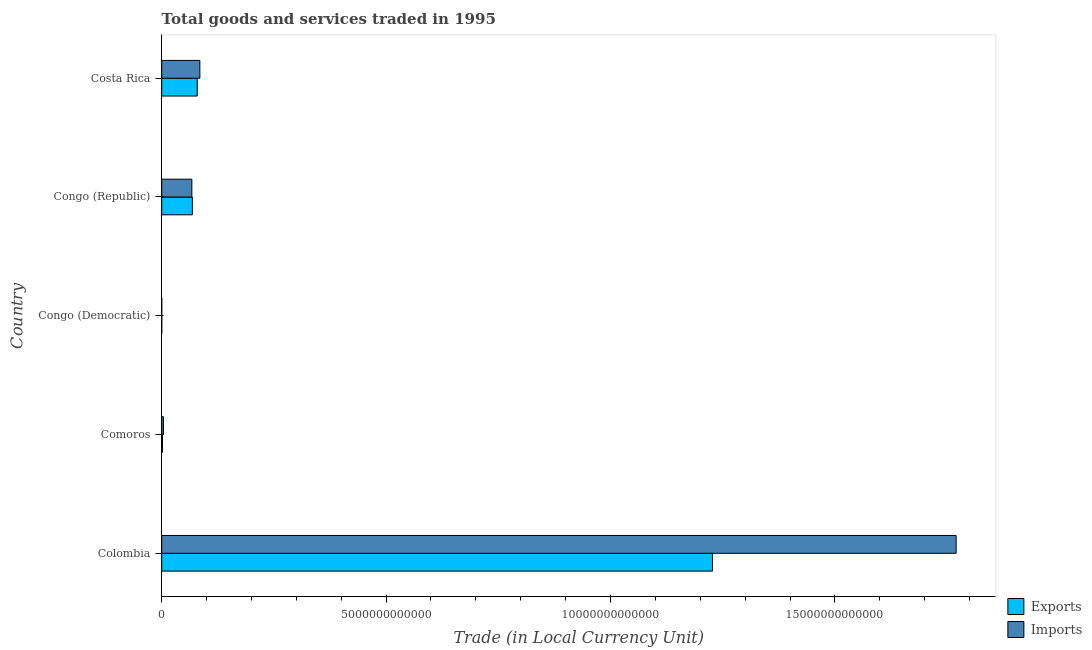How many different coloured bars are there?
Offer a very short reply. 2. How many groups of bars are there?
Ensure brevity in your answer.  5. Are the number of bars per tick equal to the number of legend labels?
Keep it short and to the point. Yes. What is the label of the 4th group of bars from the top?
Provide a succinct answer. Comoros. What is the export of goods and services in Costa Rica?
Your answer should be very brief. 7.91e+11. Across all countries, what is the maximum imports of goods and services?
Keep it short and to the point. 1.77e+13. Across all countries, what is the minimum imports of goods and services?
Your answer should be very brief. 9.41e+07. In which country was the export of goods and services minimum?
Give a very brief answer. Congo (Democratic). What is the total export of goods and services in the graph?
Your response must be concise. 1.38e+13. What is the difference between the imports of goods and services in Colombia and that in Congo (Democratic)?
Your response must be concise. 1.77e+13. What is the difference between the export of goods and services in Congo (Democratic) and the imports of goods and services in Congo (Republic)?
Your response must be concise. -6.72e+11. What is the average imports of goods and services per country?
Ensure brevity in your answer.  3.85e+12. What is the difference between the imports of goods and services and export of goods and services in Congo (Republic)?
Offer a terse response. -1.16e+1. What is the ratio of the export of goods and services in Comoros to that in Congo (Democratic)?
Your answer should be compact. 151.95. What is the difference between the highest and the second highest export of goods and services?
Offer a terse response. 1.15e+13. What is the difference between the highest and the lowest imports of goods and services?
Your answer should be compact. 1.77e+13. What does the 2nd bar from the top in Congo (Democratic) represents?
Your answer should be compact. Exports. What does the 2nd bar from the bottom in Comoros represents?
Give a very brief answer. Imports. How many bars are there?
Provide a short and direct response. 10. What is the difference between two consecutive major ticks on the X-axis?
Offer a terse response. 5.00e+12. Where does the legend appear in the graph?
Your response must be concise. Bottom right. How many legend labels are there?
Your answer should be very brief. 2. How are the legend labels stacked?
Provide a succinct answer. Vertical. What is the title of the graph?
Give a very brief answer. Total goods and services traded in 1995. Does "RDB nonconcessional" appear as one of the legend labels in the graph?
Provide a short and direct response. No. What is the label or title of the X-axis?
Make the answer very short. Trade (in Local Currency Unit). What is the label or title of the Y-axis?
Your answer should be compact. Country. What is the Trade (in Local Currency Unit) in Exports in Colombia?
Your answer should be very brief. 1.23e+13. What is the Trade (in Local Currency Unit) of Imports in Colombia?
Your answer should be very brief. 1.77e+13. What is the Trade (in Local Currency Unit) in Exports in Comoros?
Offer a terse response. 1.72e+1. What is the Trade (in Local Currency Unit) in Imports in Comoros?
Give a very brief answer. 3.87e+1. What is the Trade (in Local Currency Unit) of Exports in Congo (Democratic)?
Your response must be concise. 1.13e+08. What is the Trade (in Local Currency Unit) in Imports in Congo (Democratic)?
Your answer should be very brief. 9.41e+07. What is the Trade (in Local Currency Unit) in Exports in Congo (Republic)?
Offer a very short reply. 6.83e+11. What is the Trade (in Local Currency Unit) of Imports in Congo (Republic)?
Provide a succinct answer. 6.72e+11. What is the Trade (in Local Currency Unit) of Exports in Costa Rica?
Your response must be concise. 7.91e+11. What is the Trade (in Local Currency Unit) of Imports in Costa Rica?
Offer a terse response. 8.50e+11. Across all countries, what is the maximum Trade (in Local Currency Unit) in Exports?
Ensure brevity in your answer.  1.23e+13. Across all countries, what is the maximum Trade (in Local Currency Unit) of Imports?
Your answer should be very brief. 1.77e+13. Across all countries, what is the minimum Trade (in Local Currency Unit) of Exports?
Ensure brevity in your answer.  1.13e+08. Across all countries, what is the minimum Trade (in Local Currency Unit) in Imports?
Your response must be concise. 9.41e+07. What is the total Trade (in Local Currency Unit) of Exports in the graph?
Provide a succinct answer. 1.38e+13. What is the total Trade (in Local Currency Unit) in Imports in the graph?
Provide a succinct answer. 1.93e+13. What is the difference between the Trade (in Local Currency Unit) in Exports in Colombia and that in Comoros?
Provide a succinct answer. 1.23e+13. What is the difference between the Trade (in Local Currency Unit) of Imports in Colombia and that in Comoros?
Provide a short and direct response. 1.77e+13. What is the difference between the Trade (in Local Currency Unit) in Exports in Colombia and that in Congo (Democratic)?
Your answer should be compact. 1.23e+13. What is the difference between the Trade (in Local Currency Unit) of Imports in Colombia and that in Congo (Democratic)?
Offer a very short reply. 1.77e+13. What is the difference between the Trade (in Local Currency Unit) of Exports in Colombia and that in Congo (Republic)?
Make the answer very short. 1.16e+13. What is the difference between the Trade (in Local Currency Unit) of Imports in Colombia and that in Congo (Republic)?
Your answer should be compact. 1.70e+13. What is the difference between the Trade (in Local Currency Unit) of Exports in Colombia and that in Costa Rica?
Ensure brevity in your answer.  1.15e+13. What is the difference between the Trade (in Local Currency Unit) in Imports in Colombia and that in Costa Rica?
Your answer should be very brief. 1.69e+13. What is the difference between the Trade (in Local Currency Unit) in Exports in Comoros and that in Congo (Democratic)?
Your answer should be very brief. 1.70e+1. What is the difference between the Trade (in Local Currency Unit) in Imports in Comoros and that in Congo (Democratic)?
Keep it short and to the point. 3.86e+1. What is the difference between the Trade (in Local Currency Unit) in Exports in Comoros and that in Congo (Republic)?
Give a very brief answer. -6.66e+11. What is the difference between the Trade (in Local Currency Unit) in Imports in Comoros and that in Congo (Republic)?
Provide a succinct answer. -6.33e+11. What is the difference between the Trade (in Local Currency Unit) of Exports in Comoros and that in Costa Rica?
Provide a succinct answer. -7.74e+11. What is the difference between the Trade (in Local Currency Unit) of Imports in Comoros and that in Costa Rica?
Ensure brevity in your answer.  -8.11e+11. What is the difference between the Trade (in Local Currency Unit) of Exports in Congo (Democratic) and that in Congo (Republic)?
Your response must be concise. -6.83e+11. What is the difference between the Trade (in Local Currency Unit) of Imports in Congo (Democratic) and that in Congo (Republic)?
Give a very brief answer. -6.72e+11. What is the difference between the Trade (in Local Currency Unit) in Exports in Congo (Democratic) and that in Costa Rica?
Offer a very short reply. -7.91e+11. What is the difference between the Trade (in Local Currency Unit) in Imports in Congo (Democratic) and that in Costa Rica?
Ensure brevity in your answer.  -8.50e+11. What is the difference between the Trade (in Local Currency Unit) of Exports in Congo (Republic) and that in Costa Rica?
Make the answer very short. -1.07e+11. What is the difference between the Trade (in Local Currency Unit) of Imports in Congo (Republic) and that in Costa Rica?
Your response must be concise. -1.78e+11. What is the difference between the Trade (in Local Currency Unit) in Exports in Colombia and the Trade (in Local Currency Unit) in Imports in Comoros?
Give a very brief answer. 1.22e+13. What is the difference between the Trade (in Local Currency Unit) of Exports in Colombia and the Trade (in Local Currency Unit) of Imports in Congo (Democratic)?
Your response must be concise. 1.23e+13. What is the difference between the Trade (in Local Currency Unit) in Exports in Colombia and the Trade (in Local Currency Unit) in Imports in Congo (Republic)?
Your response must be concise. 1.16e+13. What is the difference between the Trade (in Local Currency Unit) of Exports in Colombia and the Trade (in Local Currency Unit) of Imports in Costa Rica?
Ensure brevity in your answer.  1.14e+13. What is the difference between the Trade (in Local Currency Unit) of Exports in Comoros and the Trade (in Local Currency Unit) of Imports in Congo (Democratic)?
Offer a terse response. 1.71e+1. What is the difference between the Trade (in Local Currency Unit) of Exports in Comoros and the Trade (in Local Currency Unit) of Imports in Congo (Republic)?
Offer a terse response. -6.55e+11. What is the difference between the Trade (in Local Currency Unit) in Exports in Comoros and the Trade (in Local Currency Unit) in Imports in Costa Rica?
Your answer should be compact. -8.33e+11. What is the difference between the Trade (in Local Currency Unit) in Exports in Congo (Democratic) and the Trade (in Local Currency Unit) in Imports in Congo (Republic)?
Offer a very short reply. -6.72e+11. What is the difference between the Trade (in Local Currency Unit) of Exports in Congo (Democratic) and the Trade (in Local Currency Unit) of Imports in Costa Rica?
Offer a terse response. -8.50e+11. What is the difference between the Trade (in Local Currency Unit) in Exports in Congo (Republic) and the Trade (in Local Currency Unit) in Imports in Costa Rica?
Give a very brief answer. -1.67e+11. What is the average Trade (in Local Currency Unit) of Exports per country?
Offer a terse response. 2.75e+12. What is the average Trade (in Local Currency Unit) of Imports per country?
Make the answer very short. 3.85e+12. What is the difference between the Trade (in Local Currency Unit) of Exports and Trade (in Local Currency Unit) of Imports in Colombia?
Make the answer very short. -5.43e+12. What is the difference between the Trade (in Local Currency Unit) in Exports and Trade (in Local Currency Unit) in Imports in Comoros?
Keep it short and to the point. -2.15e+1. What is the difference between the Trade (in Local Currency Unit) in Exports and Trade (in Local Currency Unit) in Imports in Congo (Democratic)?
Offer a terse response. 1.89e+07. What is the difference between the Trade (in Local Currency Unit) in Exports and Trade (in Local Currency Unit) in Imports in Congo (Republic)?
Provide a short and direct response. 1.16e+1. What is the difference between the Trade (in Local Currency Unit) of Exports and Trade (in Local Currency Unit) of Imports in Costa Rica?
Provide a succinct answer. -5.92e+1. What is the ratio of the Trade (in Local Currency Unit) of Exports in Colombia to that in Comoros?
Offer a very short reply. 715.29. What is the ratio of the Trade (in Local Currency Unit) in Imports in Colombia to that in Comoros?
Your answer should be compact. 457.53. What is the ratio of the Trade (in Local Currency Unit) in Exports in Colombia to that in Congo (Democratic)?
Give a very brief answer. 1.09e+05. What is the ratio of the Trade (in Local Currency Unit) in Imports in Colombia to that in Congo (Democratic)?
Provide a succinct answer. 1.88e+05. What is the ratio of the Trade (in Local Currency Unit) in Exports in Colombia to that in Congo (Republic)?
Offer a very short reply. 17.96. What is the ratio of the Trade (in Local Currency Unit) in Imports in Colombia to that in Congo (Republic)?
Your answer should be compact. 26.35. What is the ratio of the Trade (in Local Currency Unit) of Exports in Colombia to that in Costa Rica?
Make the answer very short. 15.52. What is the ratio of the Trade (in Local Currency Unit) in Imports in Colombia to that in Costa Rica?
Give a very brief answer. 20.83. What is the ratio of the Trade (in Local Currency Unit) of Exports in Comoros to that in Congo (Democratic)?
Your response must be concise. 151.95. What is the ratio of the Trade (in Local Currency Unit) of Imports in Comoros to that in Congo (Democratic)?
Your response must be concise. 411.34. What is the ratio of the Trade (in Local Currency Unit) of Exports in Comoros to that in Congo (Republic)?
Your response must be concise. 0.03. What is the ratio of the Trade (in Local Currency Unit) in Imports in Comoros to that in Congo (Republic)?
Offer a very short reply. 0.06. What is the ratio of the Trade (in Local Currency Unit) of Exports in Comoros to that in Costa Rica?
Provide a succinct answer. 0.02. What is the ratio of the Trade (in Local Currency Unit) of Imports in Comoros to that in Costa Rica?
Give a very brief answer. 0.05. What is the ratio of the Trade (in Local Currency Unit) in Exports in Congo (Democratic) to that in Congo (Republic)?
Your answer should be very brief. 0. What is the ratio of the Trade (in Local Currency Unit) in Imports in Congo (Democratic) to that in Costa Rica?
Your answer should be very brief. 0. What is the ratio of the Trade (in Local Currency Unit) of Exports in Congo (Republic) to that in Costa Rica?
Offer a very short reply. 0.86. What is the ratio of the Trade (in Local Currency Unit) of Imports in Congo (Republic) to that in Costa Rica?
Your answer should be very brief. 0.79. What is the difference between the highest and the second highest Trade (in Local Currency Unit) of Exports?
Provide a succinct answer. 1.15e+13. What is the difference between the highest and the second highest Trade (in Local Currency Unit) of Imports?
Offer a terse response. 1.69e+13. What is the difference between the highest and the lowest Trade (in Local Currency Unit) in Exports?
Provide a short and direct response. 1.23e+13. What is the difference between the highest and the lowest Trade (in Local Currency Unit) in Imports?
Your answer should be compact. 1.77e+13. 